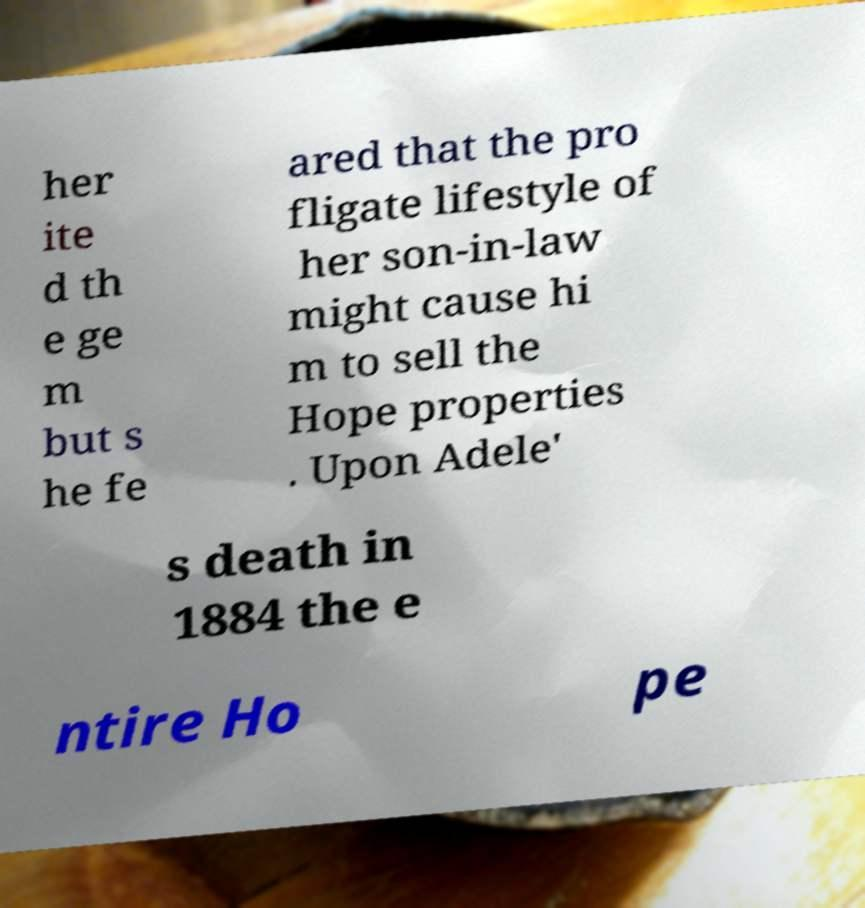Can you read and provide the text displayed in the image?This photo seems to have some interesting text. Can you extract and type it out for me? her ite d th e ge m but s he fe ared that the pro fligate lifestyle of her son-in-law might cause hi m to sell the Hope properties . Upon Adele' s death in 1884 the e ntire Ho pe 